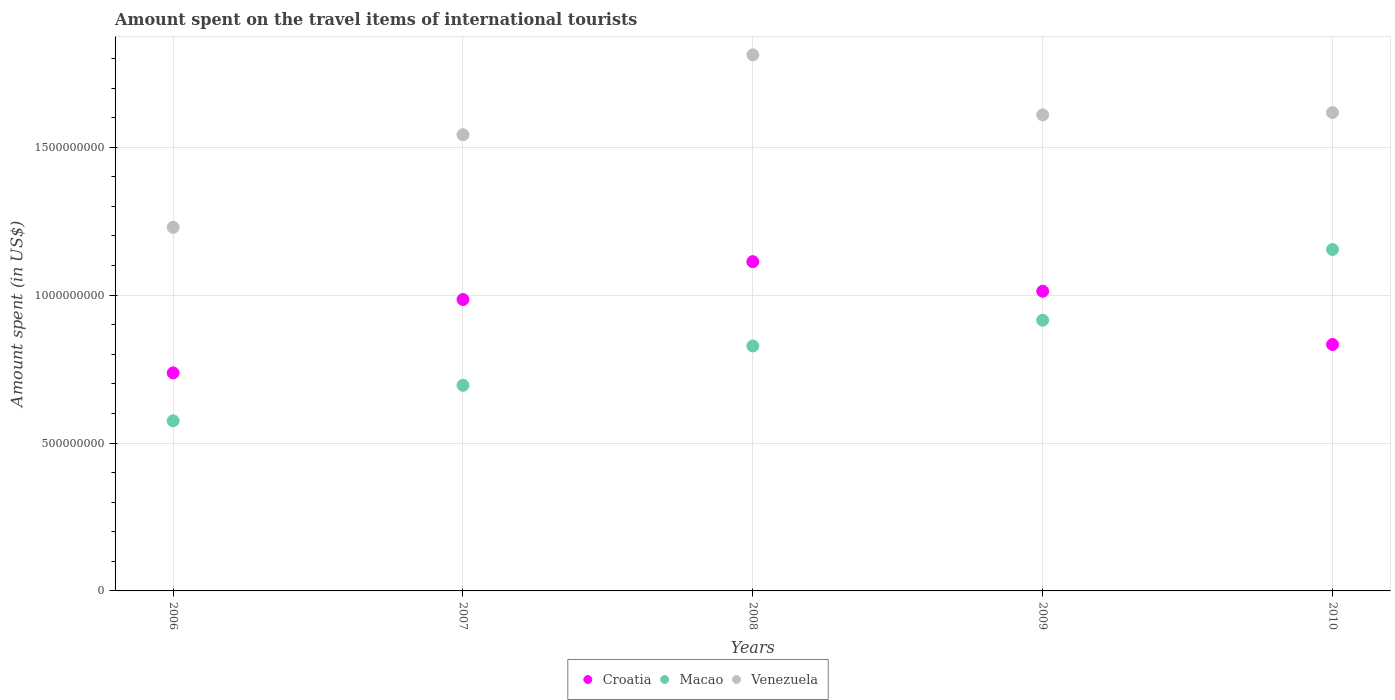What is the amount spent on the travel items of international tourists in Venezuela in 2007?
Give a very brief answer. 1.54e+09. Across all years, what is the maximum amount spent on the travel items of international tourists in Croatia?
Ensure brevity in your answer.  1.11e+09. Across all years, what is the minimum amount spent on the travel items of international tourists in Macao?
Provide a short and direct response. 5.75e+08. In which year was the amount spent on the travel items of international tourists in Macao maximum?
Your answer should be very brief. 2010. What is the total amount spent on the travel items of international tourists in Croatia in the graph?
Ensure brevity in your answer.  4.68e+09. What is the difference between the amount spent on the travel items of international tourists in Venezuela in 2007 and that in 2008?
Give a very brief answer. -2.70e+08. What is the difference between the amount spent on the travel items of international tourists in Macao in 2009 and the amount spent on the travel items of international tourists in Croatia in 2010?
Keep it short and to the point. 8.20e+07. What is the average amount spent on the travel items of international tourists in Venezuela per year?
Your response must be concise. 1.56e+09. In the year 2006, what is the difference between the amount spent on the travel items of international tourists in Venezuela and amount spent on the travel items of international tourists in Macao?
Give a very brief answer. 6.54e+08. What is the ratio of the amount spent on the travel items of international tourists in Croatia in 2006 to that in 2009?
Provide a succinct answer. 0.73. What is the difference between the highest and the second highest amount spent on the travel items of international tourists in Macao?
Offer a very short reply. 2.39e+08. What is the difference between the highest and the lowest amount spent on the travel items of international tourists in Croatia?
Give a very brief answer. 3.76e+08. Is the sum of the amount spent on the travel items of international tourists in Venezuela in 2007 and 2008 greater than the maximum amount spent on the travel items of international tourists in Croatia across all years?
Your answer should be compact. Yes. Does the amount spent on the travel items of international tourists in Macao monotonically increase over the years?
Your answer should be compact. Yes. Is the amount spent on the travel items of international tourists in Croatia strictly greater than the amount spent on the travel items of international tourists in Macao over the years?
Keep it short and to the point. No. Is the amount spent on the travel items of international tourists in Croatia strictly less than the amount spent on the travel items of international tourists in Venezuela over the years?
Offer a very short reply. Yes. How many dotlines are there?
Your answer should be compact. 3. How many years are there in the graph?
Ensure brevity in your answer.  5. What is the difference between two consecutive major ticks on the Y-axis?
Provide a succinct answer. 5.00e+08. Does the graph contain grids?
Offer a very short reply. Yes. Where does the legend appear in the graph?
Ensure brevity in your answer.  Bottom center. How are the legend labels stacked?
Provide a short and direct response. Horizontal. What is the title of the graph?
Keep it short and to the point. Amount spent on the travel items of international tourists. Does "Lebanon" appear as one of the legend labels in the graph?
Offer a terse response. No. What is the label or title of the Y-axis?
Keep it short and to the point. Amount spent (in US$). What is the Amount spent (in US$) of Croatia in 2006?
Provide a succinct answer. 7.37e+08. What is the Amount spent (in US$) in Macao in 2006?
Your answer should be very brief. 5.75e+08. What is the Amount spent (in US$) of Venezuela in 2006?
Provide a short and direct response. 1.23e+09. What is the Amount spent (in US$) of Croatia in 2007?
Keep it short and to the point. 9.85e+08. What is the Amount spent (in US$) in Macao in 2007?
Provide a short and direct response. 6.95e+08. What is the Amount spent (in US$) of Venezuela in 2007?
Make the answer very short. 1.54e+09. What is the Amount spent (in US$) of Croatia in 2008?
Your response must be concise. 1.11e+09. What is the Amount spent (in US$) in Macao in 2008?
Provide a succinct answer. 8.28e+08. What is the Amount spent (in US$) in Venezuela in 2008?
Give a very brief answer. 1.81e+09. What is the Amount spent (in US$) in Croatia in 2009?
Make the answer very short. 1.01e+09. What is the Amount spent (in US$) of Macao in 2009?
Your answer should be compact. 9.15e+08. What is the Amount spent (in US$) of Venezuela in 2009?
Ensure brevity in your answer.  1.61e+09. What is the Amount spent (in US$) of Croatia in 2010?
Give a very brief answer. 8.33e+08. What is the Amount spent (in US$) of Macao in 2010?
Give a very brief answer. 1.15e+09. What is the Amount spent (in US$) of Venezuela in 2010?
Your answer should be compact. 1.62e+09. Across all years, what is the maximum Amount spent (in US$) of Croatia?
Provide a short and direct response. 1.11e+09. Across all years, what is the maximum Amount spent (in US$) of Macao?
Offer a very short reply. 1.15e+09. Across all years, what is the maximum Amount spent (in US$) of Venezuela?
Offer a terse response. 1.81e+09. Across all years, what is the minimum Amount spent (in US$) in Croatia?
Keep it short and to the point. 7.37e+08. Across all years, what is the minimum Amount spent (in US$) in Macao?
Give a very brief answer. 5.75e+08. Across all years, what is the minimum Amount spent (in US$) in Venezuela?
Keep it short and to the point. 1.23e+09. What is the total Amount spent (in US$) of Croatia in the graph?
Your answer should be compact. 4.68e+09. What is the total Amount spent (in US$) of Macao in the graph?
Offer a terse response. 4.17e+09. What is the total Amount spent (in US$) in Venezuela in the graph?
Give a very brief answer. 7.81e+09. What is the difference between the Amount spent (in US$) in Croatia in 2006 and that in 2007?
Your answer should be very brief. -2.48e+08. What is the difference between the Amount spent (in US$) of Macao in 2006 and that in 2007?
Provide a succinct answer. -1.20e+08. What is the difference between the Amount spent (in US$) in Venezuela in 2006 and that in 2007?
Ensure brevity in your answer.  -3.13e+08. What is the difference between the Amount spent (in US$) of Croatia in 2006 and that in 2008?
Offer a terse response. -3.76e+08. What is the difference between the Amount spent (in US$) in Macao in 2006 and that in 2008?
Provide a succinct answer. -2.53e+08. What is the difference between the Amount spent (in US$) in Venezuela in 2006 and that in 2008?
Your response must be concise. -5.83e+08. What is the difference between the Amount spent (in US$) of Croatia in 2006 and that in 2009?
Make the answer very short. -2.76e+08. What is the difference between the Amount spent (in US$) in Macao in 2006 and that in 2009?
Your answer should be very brief. -3.40e+08. What is the difference between the Amount spent (in US$) of Venezuela in 2006 and that in 2009?
Ensure brevity in your answer.  -3.80e+08. What is the difference between the Amount spent (in US$) of Croatia in 2006 and that in 2010?
Provide a short and direct response. -9.60e+07. What is the difference between the Amount spent (in US$) of Macao in 2006 and that in 2010?
Your answer should be compact. -5.79e+08. What is the difference between the Amount spent (in US$) in Venezuela in 2006 and that in 2010?
Keep it short and to the point. -3.88e+08. What is the difference between the Amount spent (in US$) of Croatia in 2007 and that in 2008?
Ensure brevity in your answer.  -1.28e+08. What is the difference between the Amount spent (in US$) in Macao in 2007 and that in 2008?
Keep it short and to the point. -1.33e+08. What is the difference between the Amount spent (in US$) in Venezuela in 2007 and that in 2008?
Your answer should be very brief. -2.70e+08. What is the difference between the Amount spent (in US$) in Croatia in 2007 and that in 2009?
Provide a succinct answer. -2.80e+07. What is the difference between the Amount spent (in US$) in Macao in 2007 and that in 2009?
Make the answer very short. -2.20e+08. What is the difference between the Amount spent (in US$) in Venezuela in 2007 and that in 2009?
Your answer should be compact. -6.70e+07. What is the difference between the Amount spent (in US$) of Croatia in 2007 and that in 2010?
Your answer should be very brief. 1.52e+08. What is the difference between the Amount spent (in US$) in Macao in 2007 and that in 2010?
Provide a short and direct response. -4.59e+08. What is the difference between the Amount spent (in US$) in Venezuela in 2007 and that in 2010?
Offer a very short reply. -7.50e+07. What is the difference between the Amount spent (in US$) in Macao in 2008 and that in 2009?
Your answer should be very brief. -8.70e+07. What is the difference between the Amount spent (in US$) in Venezuela in 2008 and that in 2009?
Your answer should be compact. 2.03e+08. What is the difference between the Amount spent (in US$) in Croatia in 2008 and that in 2010?
Your answer should be very brief. 2.80e+08. What is the difference between the Amount spent (in US$) of Macao in 2008 and that in 2010?
Keep it short and to the point. -3.26e+08. What is the difference between the Amount spent (in US$) of Venezuela in 2008 and that in 2010?
Provide a short and direct response. 1.95e+08. What is the difference between the Amount spent (in US$) in Croatia in 2009 and that in 2010?
Ensure brevity in your answer.  1.80e+08. What is the difference between the Amount spent (in US$) in Macao in 2009 and that in 2010?
Offer a terse response. -2.39e+08. What is the difference between the Amount spent (in US$) of Venezuela in 2009 and that in 2010?
Your response must be concise. -8.00e+06. What is the difference between the Amount spent (in US$) of Croatia in 2006 and the Amount spent (in US$) of Macao in 2007?
Ensure brevity in your answer.  4.20e+07. What is the difference between the Amount spent (in US$) in Croatia in 2006 and the Amount spent (in US$) in Venezuela in 2007?
Provide a short and direct response. -8.05e+08. What is the difference between the Amount spent (in US$) of Macao in 2006 and the Amount spent (in US$) of Venezuela in 2007?
Give a very brief answer. -9.67e+08. What is the difference between the Amount spent (in US$) in Croatia in 2006 and the Amount spent (in US$) in Macao in 2008?
Provide a short and direct response. -9.10e+07. What is the difference between the Amount spent (in US$) of Croatia in 2006 and the Amount spent (in US$) of Venezuela in 2008?
Give a very brief answer. -1.08e+09. What is the difference between the Amount spent (in US$) in Macao in 2006 and the Amount spent (in US$) in Venezuela in 2008?
Your answer should be compact. -1.24e+09. What is the difference between the Amount spent (in US$) in Croatia in 2006 and the Amount spent (in US$) in Macao in 2009?
Offer a very short reply. -1.78e+08. What is the difference between the Amount spent (in US$) in Croatia in 2006 and the Amount spent (in US$) in Venezuela in 2009?
Your answer should be compact. -8.72e+08. What is the difference between the Amount spent (in US$) in Macao in 2006 and the Amount spent (in US$) in Venezuela in 2009?
Your response must be concise. -1.03e+09. What is the difference between the Amount spent (in US$) of Croatia in 2006 and the Amount spent (in US$) of Macao in 2010?
Provide a short and direct response. -4.17e+08. What is the difference between the Amount spent (in US$) of Croatia in 2006 and the Amount spent (in US$) of Venezuela in 2010?
Your answer should be compact. -8.80e+08. What is the difference between the Amount spent (in US$) in Macao in 2006 and the Amount spent (in US$) in Venezuela in 2010?
Your answer should be compact. -1.04e+09. What is the difference between the Amount spent (in US$) of Croatia in 2007 and the Amount spent (in US$) of Macao in 2008?
Offer a very short reply. 1.57e+08. What is the difference between the Amount spent (in US$) of Croatia in 2007 and the Amount spent (in US$) of Venezuela in 2008?
Your answer should be very brief. -8.27e+08. What is the difference between the Amount spent (in US$) in Macao in 2007 and the Amount spent (in US$) in Venezuela in 2008?
Offer a very short reply. -1.12e+09. What is the difference between the Amount spent (in US$) in Croatia in 2007 and the Amount spent (in US$) in Macao in 2009?
Give a very brief answer. 7.00e+07. What is the difference between the Amount spent (in US$) in Croatia in 2007 and the Amount spent (in US$) in Venezuela in 2009?
Give a very brief answer. -6.24e+08. What is the difference between the Amount spent (in US$) in Macao in 2007 and the Amount spent (in US$) in Venezuela in 2009?
Your answer should be compact. -9.14e+08. What is the difference between the Amount spent (in US$) of Croatia in 2007 and the Amount spent (in US$) of Macao in 2010?
Provide a succinct answer. -1.69e+08. What is the difference between the Amount spent (in US$) of Croatia in 2007 and the Amount spent (in US$) of Venezuela in 2010?
Your answer should be compact. -6.32e+08. What is the difference between the Amount spent (in US$) in Macao in 2007 and the Amount spent (in US$) in Venezuela in 2010?
Your response must be concise. -9.22e+08. What is the difference between the Amount spent (in US$) of Croatia in 2008 and the Amount spent (in US$) of Macao in 2009?
Your answer should be very brief. 1.98e+08. What is the difference between the Amount spent (in US$) in Croatia in 2008 and the Amount spent (in US$) in Venezuela in 2009?
Your answer should be very brief. -4.96e+08. What is the difference between the Amount spent (in US$) of Macao in 2008 and the Amount spent (in US$) of Venezuela in 2009?
Offer a very short reply. -7.81e+08. What is the difference between the Amount spent (in US$) in Croatia in 2008 and the Amount spent (in US$) in Macao in 2010?
Offer a very short reply. -4.10e+07. What is the difference between the Amount spent (in US$) of Croatia in 2008 and the Amount spent (in US$) of Venezuela in 2010?
Keep it short and to the point. -5.04e+08. What is the difference between the Amount spent (in US$) in Macao in 2008 and the Amount spent (in US$) in Venezuela in 2010?
Your answer should be very brief. -7.89e+08. What is the difference between the Amount spent (in US$) in Croatia in 2009 and the Amount spent (in US$) in Macao in 2010?
Give a very brief answer. -1.41e+08. What is the difference between the Amount spent (in US$) of Croatia in 2009 and the Amount spent (in US$) of Venezuela in 2010?
Keep it short and to the point. -6.04e+08. What is the difference between the Amount spent (in US$) in Macao in 2009 and the Amount spent (in US$) in Venezuela in 2010?
Provide a succinct answer. -7.02e+08. What is the average Amount spent (in US$) in Croatia per year?
Your response must be concise. 9.36e+08. What is the average Amount spent (in US$) of Macao per year?
Your answer should be compact. 8.33e+08. What is the average Amount spent (in US$) in Venezuela per year?
Your response must be concise. 1.56e+09. In the year 2006, what is the difference between the Amount spent (in US$) in Croatia and Amount spent (in US$) in Macao?
Offer a very short reply. 1.62e+08. In the year 2006, what is the difference between the Amount spent (in US$) of Croatia and Amount spent (in US$) of Venezuela?
Your response must be concise. -4.92e+08. In the year 2006, what is the difference between the Amount spent (in US$) in Macao and Amount spent (in US$) in Venezuela?
Your answer should be very brief. -6.54e+08. In the year 2007, what is the difference between the Amount spent (in US$) of Croatia and Amount spent (in US$) of Macao?
Your answer should be compact. 2.90e+08. In the year 2007, what is the difference between the Amount spent (in US$) of Croatia and Amount spent (in US$) of Venezuela?
Provide a succinct answer. -5.57e+08. In the year 2007, what is the difference between the Amount spent (in US$) in Macao and Amount spent (in US$) in Venezuela?
Offer a terse response. -8.47e+08. In the year 2008, what is the difference between the Amount spent (in US$) in Croatia and Amount spent (in US$) in Macao?
Ensure brevity in your answer.  2.85e+08. In the year 2008, what is the difference between the Amount spent (in US$) of Croatia and Amount spent (in US$) of Venezuela?
Your answer should be very brief. -6.99e+08. In the year 2008, what is the difference between the Amount spent (in US$) in Macao and Amount spent (in US$) in Venezuela?
Ensure brevity in your answer.  -9.84e+08. In the year 2009, what is the difference between the Amount spent (in US$) of Croatia and Amount spent (in US$) of Macao?
Offer a terse response. 9.80e+07. In the year 2009, what is the difference between the Amount spent (in US$) in Croatia and Amount spent (in US$) in Venezuela?
Your answer should be very brief. -5.96e+08. In the year 2009, what is the difference between the Amount spent (in US$) of Macao and Amount spent (in US$) of Venezuela?
Ensure brevity in your answer.  -6.94e+08. In the year 2010, what is the difference between the Amount spent (in US$) in Croatia and Amount spent (in US$) in Macao?
Ensure brevity in your answer.  -3.21e+08. In the year 2010, what is the difference between the Amount spent (in US$) of Croatia and Amount spent (in US$) of Venezuela?
Offer a terse response. -7.84e+08. In the year 2010, what is the difference between the Amount spent (in US$) in Macao and Amount spent (in US$) in Venezuela?
Give a very brief answer. -4.63e+08. What is the ratio of the Amount spent (in US$) of Croatia in 2006 to that in 2007?
Your answer should be compact. 0.75. What is the ratio of the Amount spent (in US$) of Macao in 2006 to that in 2007?
Provide a succinct answer. 0.83. What is the ratio of the Amount spent (in US$) in Venezuela in 2006 to that in 2007?
Provide a short and direct response. 0.8. What is the ratio of the Amount spent (in US$) of Croatia in 2006 to that in 2008?
Offer a very short reply. 0.66. What is the ratio of the Amount spent (in US$) of Macao in 2006 to that in 2008?
Ensure brevity in your answer.  0.69. What is the ratio of the Amount spent (in US$) in Venezuela in 2006 to that in 2008?
Ensure brevity in your answer.  0.68. What is the ratio of the Amount spent (in US$) of Croatia in 2006 to that in 2009?
Your answer should be very brief. 0.73. What is the ratio of the Amount spent (in US$) of Macao in 2006 to that in 2009?
Keep it short and to the point. 0.63. What is the ratio of the Amount spent (in US$) in Venezuela in 2006 to that in 2009?
Keep it short and to the point. 0.76. What is the ratio of the Amount spent (in US$) of Croatia in 2006 to that in 2010?
Provide a short and direct response. 0.88. What is the ratio of the Amount spent (in US$) of Macao in 2006 to that in 2010?
Provide a succinct answer. 0.5. What is the ratio of the Amount spent (in US$) of Venezuela in 2006 to that in 2010?
Offer a terse response. 0.76. What is the ratio of the Amount spent (in US$) in Croatia in 2007 to that in 2008?
Make the answer very short. 0.89. What is the ratio of the Amount spent (in US$) in Macao in 2007 to that in 2008?
Offer a very short reply. 0.84. What is the ratio of the Amount spent (in US$) in Venezuela in 2007 to that in 2008?
Your response must be concise. 0.85. What is the ratio of the Amount spent (in US$) in Croatia in 2007 to that in 2009?
Keep it short and to the point. 0.97. What is the ratio of the Amount spent (in US$) in Macao in 2007 to that in 2009?
Your response must be concise. 0.76. What is the ratio of the Amount spent (in US$) in Venezuela in 2007 to that in 2009?
Make the answer very short. 0.96. What is the ratio of the Amount spent (in US$) of Croatia in 2007 to that in 2010?
Ensure brevity in your answer.  1.18. What is the ratio of the Amount spent (in US$) in Macao in 2007 to that in 2010?
Give a very brief answer. 0.6. What is the ratio of the Amount spent (in US$) in Venezuela in 2007 to that in 2010?
Provide a succinct answer. 0.95. What is the ratio of the Amount spent (in US$) of Croatia in 2008 to that in 2009?
Provide a succinct answer. 1.1. What is the ratio of the Amount spent (in US$) of Macao in 2008 to that in 2009?
Offer a terse response. 0.9. What is the ratio of the Amount spent (in US$) in Venezuela in 2008 to that in 2009?
Provide a short and direct response. 1.13. What is the ratio of the Amount spent (in US$) in Croatia in 2008 to that in 2010?
Give a very brief answer. 1.34. What is the ratio of the Amount spent (in US$) in Macao in 2008 to that in 2010?
Keep it short and to the point. 0.72. What is the ratio of the Amount spent (in US$) in Venezuela in 2008 to that in 2010?
Offer a terse response. 1.12. What is the ratio of the Amount spent (in US$) in Croatia in 2009 to that in 2010?
Give a very brief answer. 1.22. What is the ratio of the Amount spent (in US$) of Macao in 2009 to that in 2010?
Make the answer very short. 0.79. What is the difference between the highest and the second highest Amount spent (in US$) in Croatia?
Offer a very short reply. 1.00e+08. What is the difference between the highest and the second highest Amount spent (in US$) in Macao?
Your answer should be compact. 2.39e+08. What is the difference between the highest and the second highest Amount spent (in US$) in Venezuela?
Your answer should be very brief. 1.95e+08. What is the difference between the highest and the lowest Amount spent (in US$) of Croatia?
Provide a short and direct response. 3.76e+08. What is the difference between the highest and the lowest Amount spent (in US$) of Macao?
Offer a very short reply. 5.79e+08. What is the difference between the highest and the lowest Amount spent (in US$) of Venezuela?
Offer a terse response. 5.83e+08. 